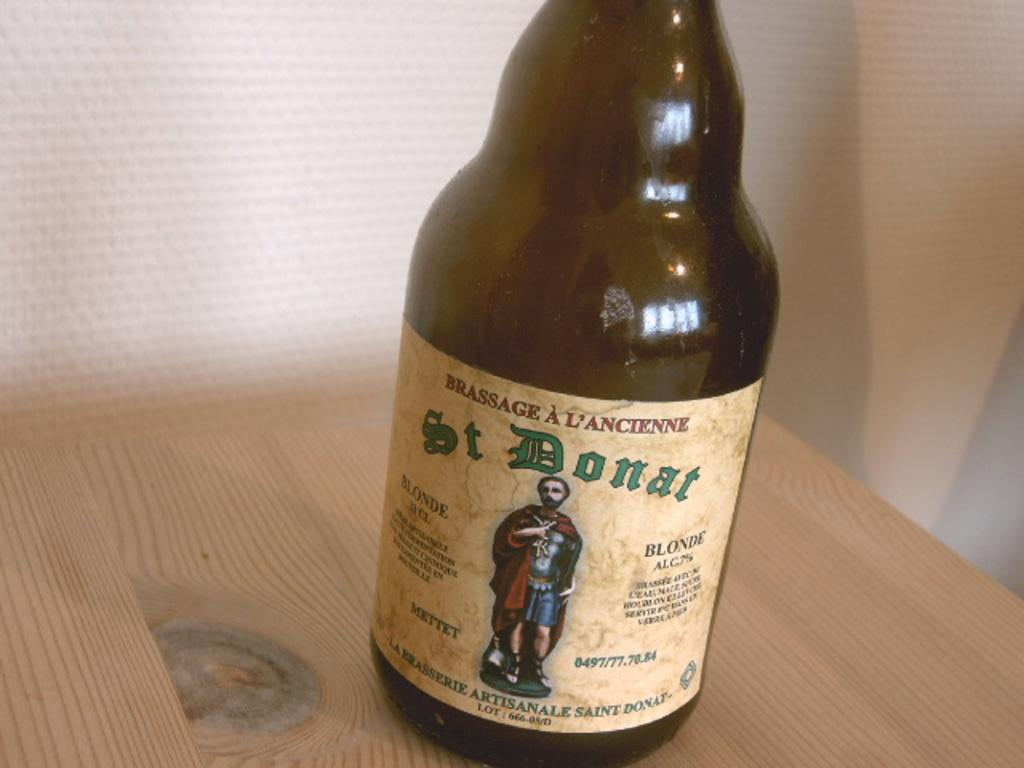What object is visible in the image? There is a bottle in the image. Where is the bottle located in the image? The bottle is placed on a table. How does the bottle compare to the amount of money in the image? There is no mention of money in the image, so it cannot be compared to the bottle. 